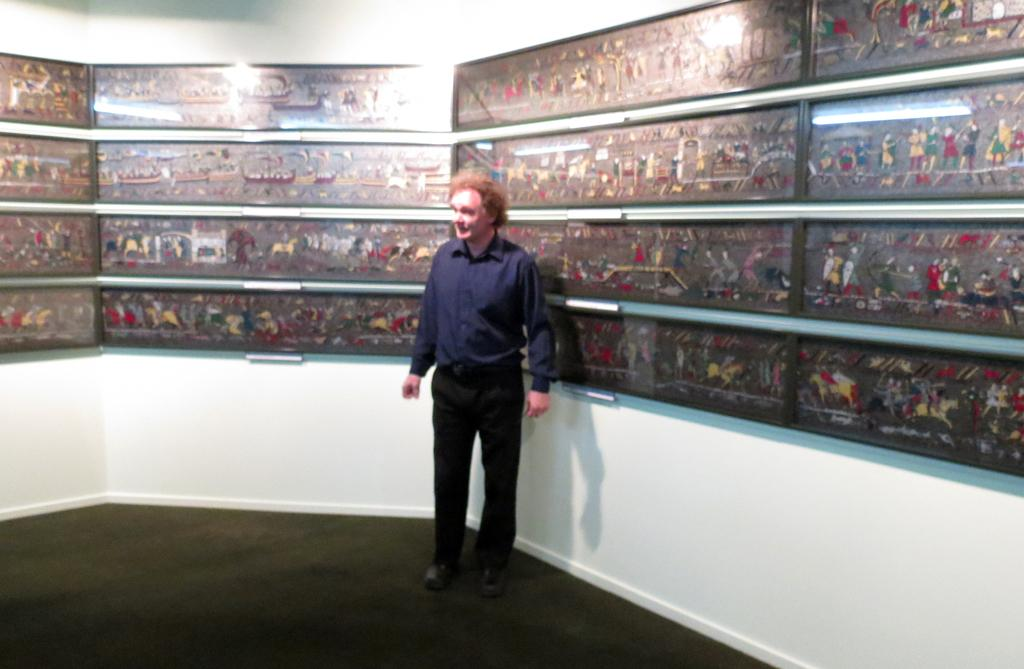Who is the main subject in the image? There is a man in the image. Where is the man positioned in the image? The man is standing in the middle of the image. What is the man wearing? The man is wearing a blue color shirt and a black color trouser. What can be seen behind the man in the image? There is a light behind the man. What is present on the right side of the image? There are different pictures on the right side of the image. What type of liquid is the man holding in the image? There is no liquid visible in the image; the man is not holding anything. 